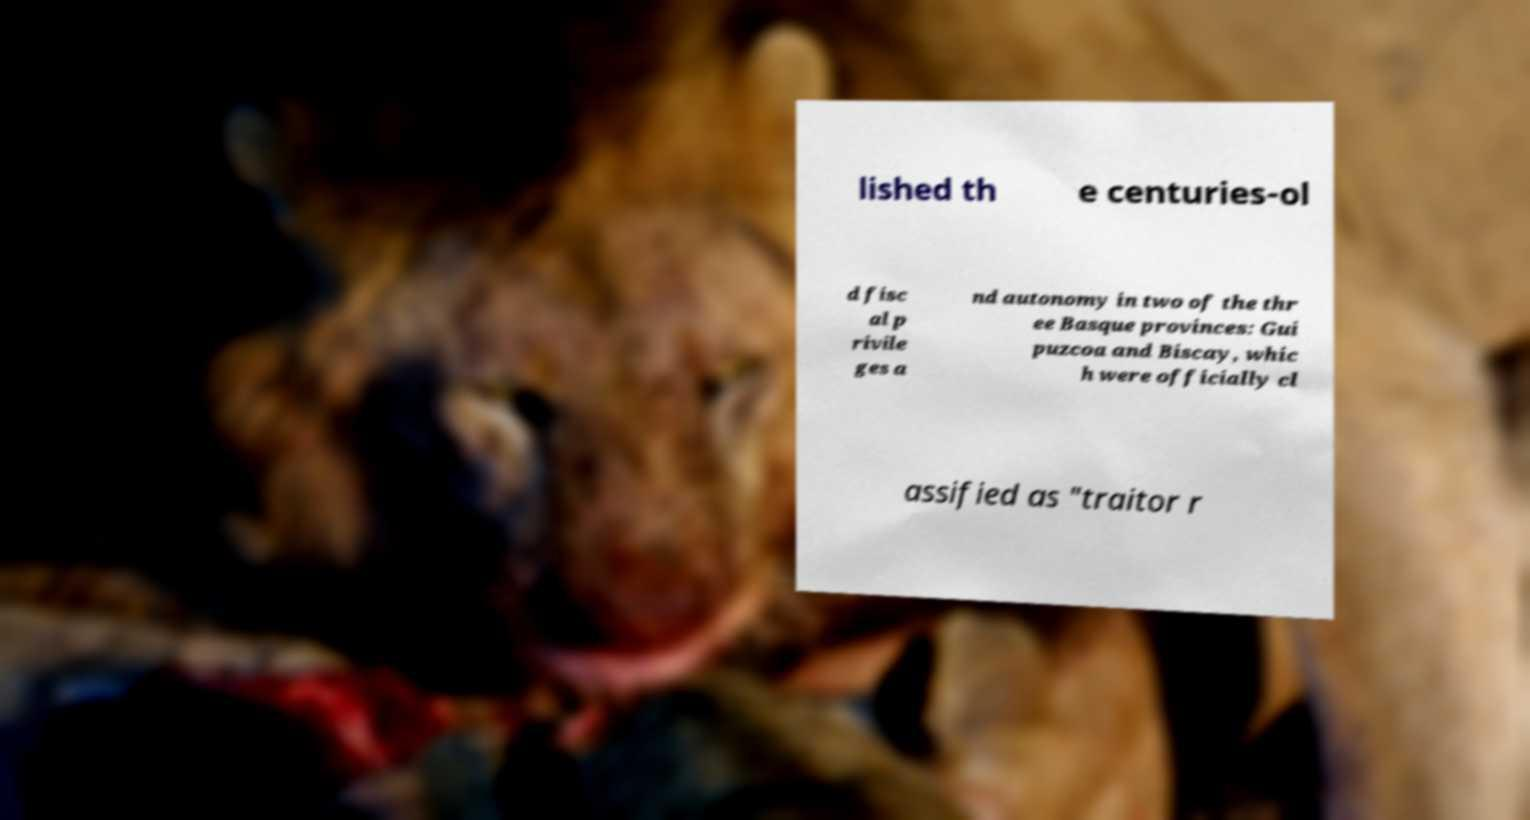Can you read and provide the text displayed in the image?This photo seems to have some interesting text. Can you extract and type it out for me? lished th e centuries-ol d fisc al p rivile ges a nd autonomy in two of the thr ee Basque provinces: Gui puzcoa and Biscay, whic h were officially cl assified as "traitor r 